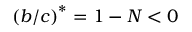<formula> <loc_0><loc_0><loc_500><loc_500>\left ( b / c \right ) ^ { \ast } = 1 - N < 0</formula> 